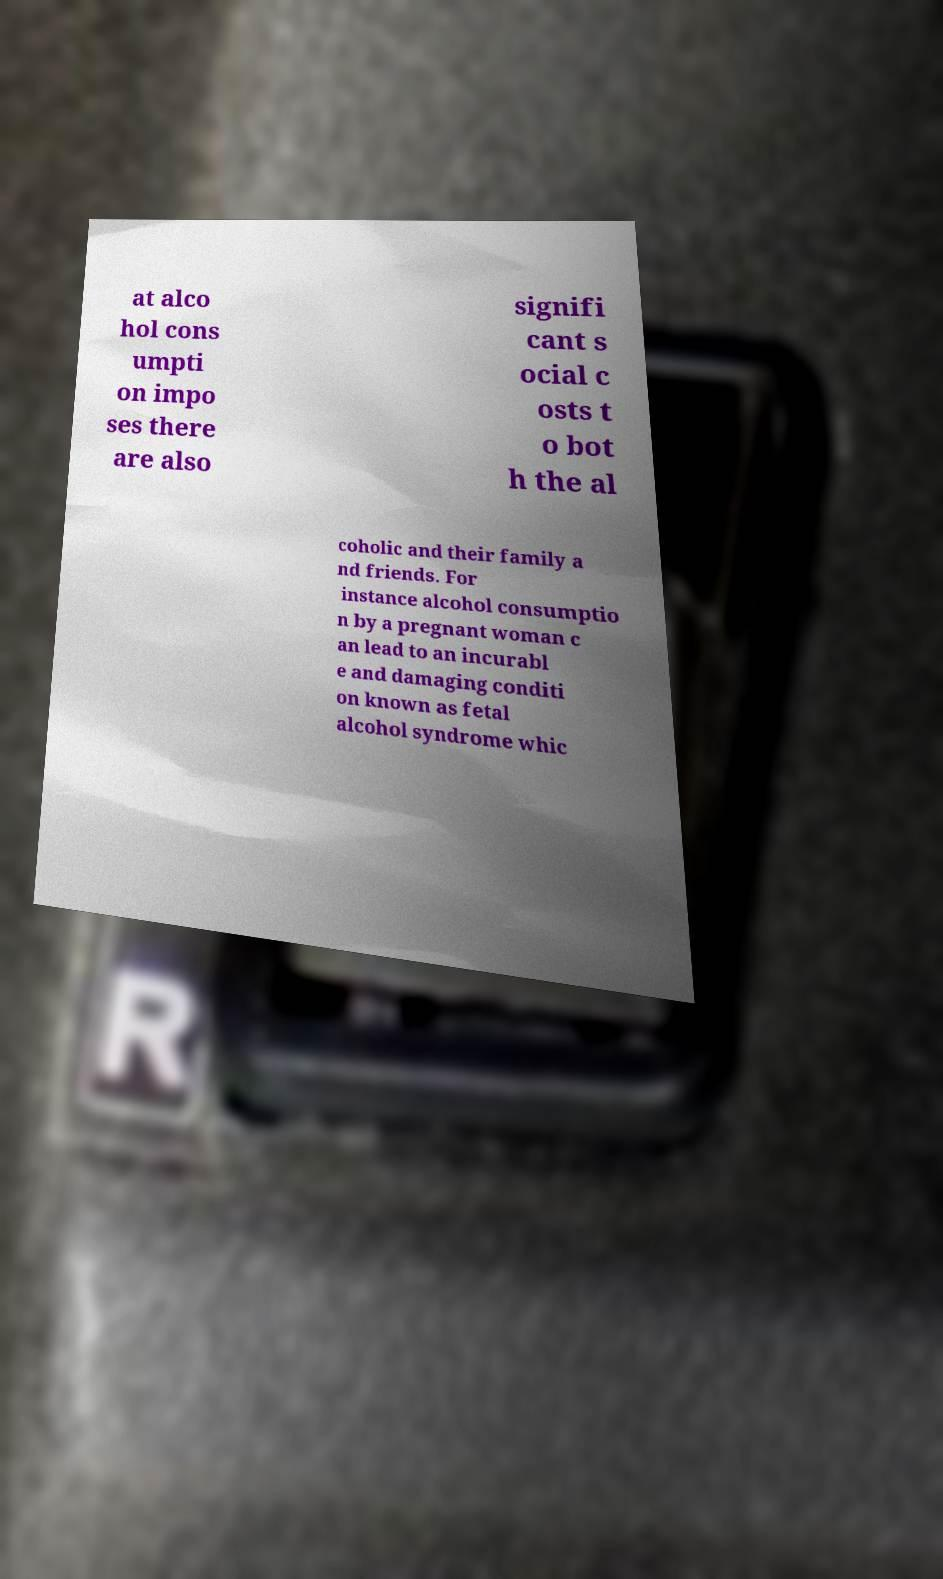Please identify and transcribe the text found in this image. at alco hol cons umpti on impo ses there are also signifi cant s ocial c osts t o bot h the al coholic and their family a nd friends. For instance alcohol consumptio n by a pregnant woman c an lead to an incurabl e and damaging conditi on known as fetal alcohol syndrome whic 